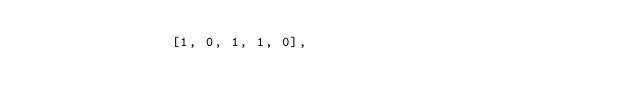<code> <loc_0><loc_0><loc_500><loc_500><_Python_>                [1, 0, 1, 1, 0],</code> 